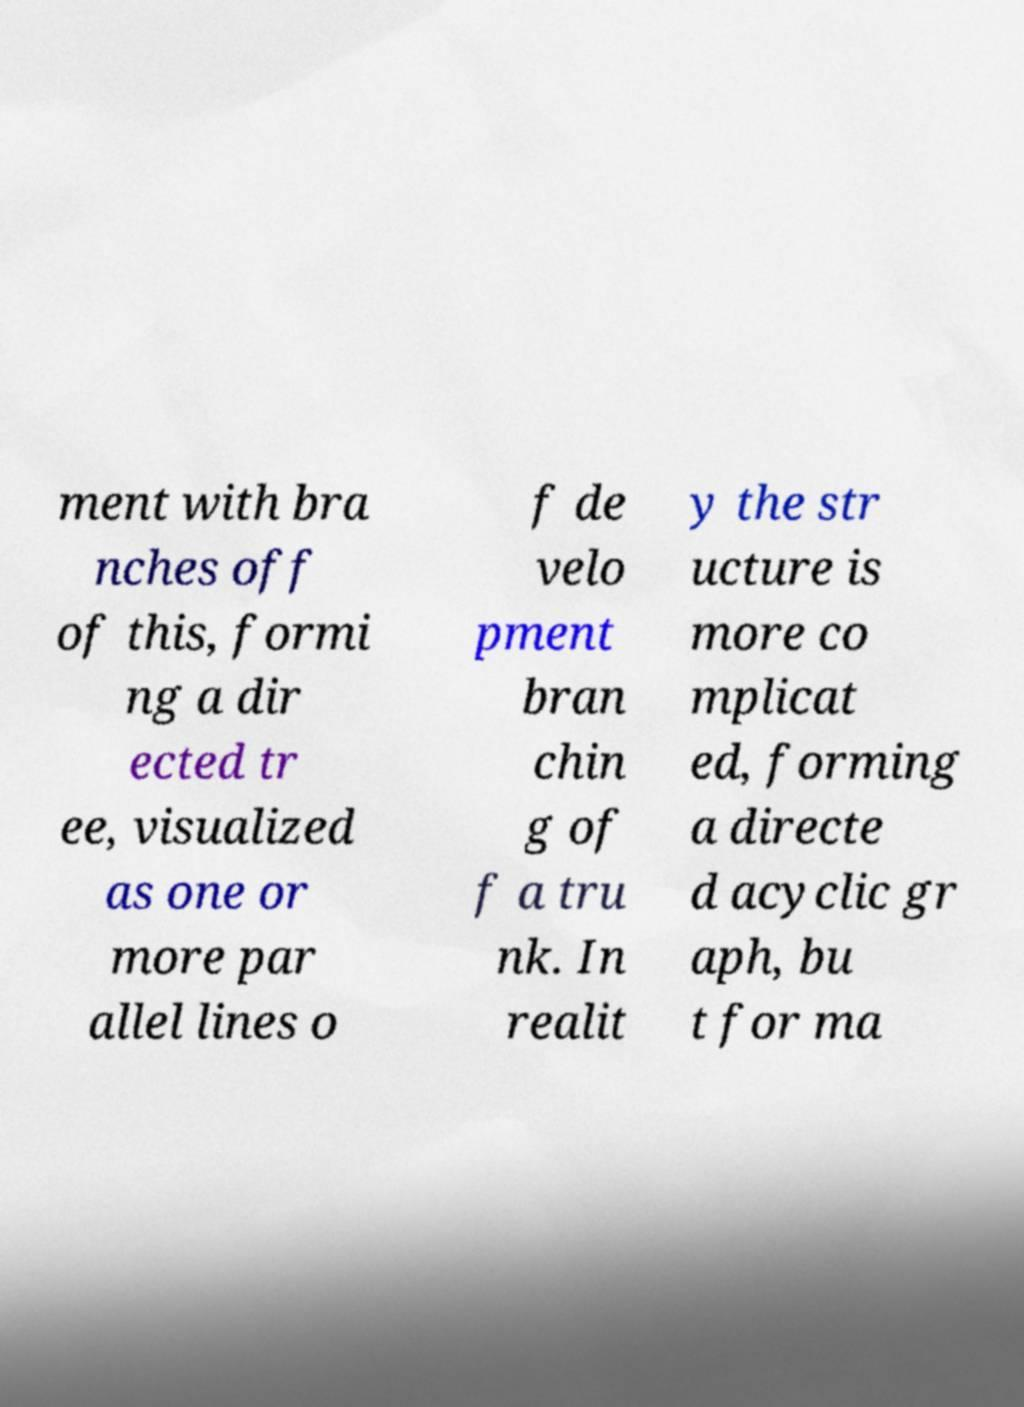There's text embedded in this image that I need extracted. Can you transcribe it verbatim? ment with bra nches off of this, formi ng a dir ected tr ee, visualized as one or more par allel lines o f de velo pment bran chin g of f a tru nk. In realit y the str ucture is more co mplicat ed, forming a directe d acyclic gr aph, bu t for ma 